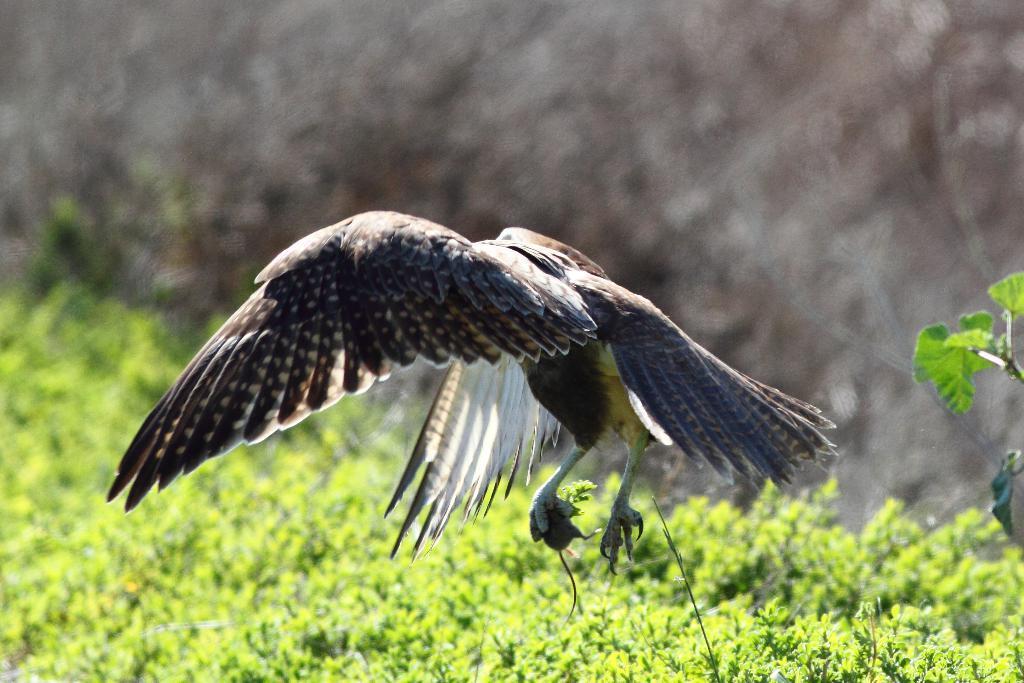In one or two sentences, can you explain what this image depicts? In the foreground of this image, there is a bird holding a rat with its claw in the air. On the bottom, there is greenery and on the top, there is the sky and the cloud. 